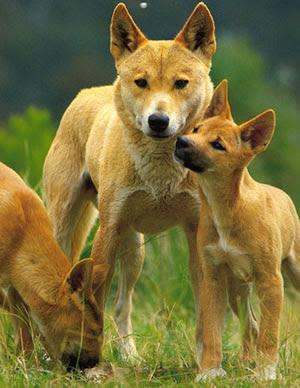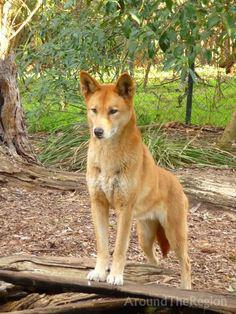The first image is the image on the left, the second image is the image on the right. For the images displayed, is the sentence "The wild dog in the image on the left is lying on the ground." factually correct? Answer yes or no. No. The first image is the image on the left, the second image is the image on the right. Analyze the images presented: Is the assertion "An image contains exactly one wild dog, standing with its body facing left and head turned." valid? Answer yes or no. No. 